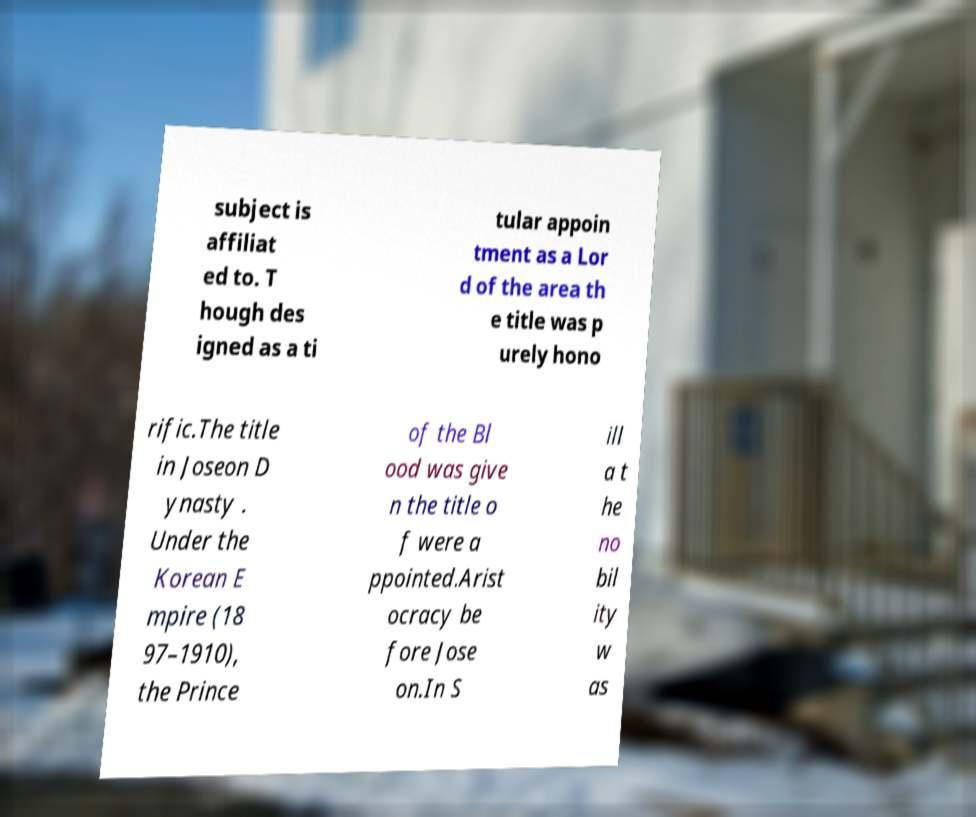I need the written content from this picture converted into text. Can you do that? subject is affiliat ed to. T hough des igned as a ti tular appoin tment as a Lor d of the area th e title was p urely hono rific.The title in Joseon D ynasty . Under the Korean E mpire (18 97–1910), the Prince of the Bl ood was give n the title o f were a ppointed.Arist ocracy be fore Jose on.In S ill a t he no bil ity w as 